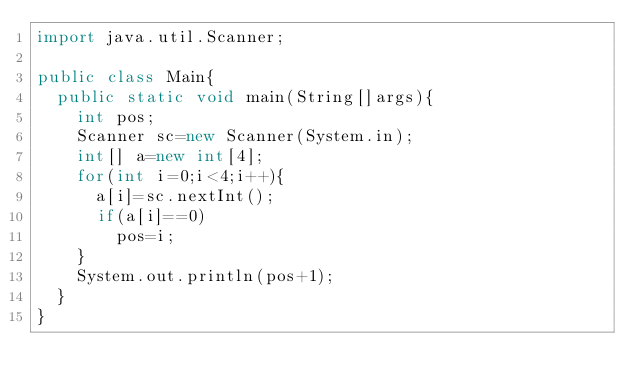Convert code to text. <code><loc_0><loc_0><loc_500><loc_500><_Java_>import java.util.Scanner;

public class Main{
  public static void main(String[]args){
    int pos;
    Scanner sc=new Scanner(System.in);
    int[] a=new int[4];
    for(int i=0;i<4;i++){
      a[i]=sc.nextInt();
      if(a[i]==0)
        pos=i;
    }
    System.out.println(pos+1);
  }
}
</code> 